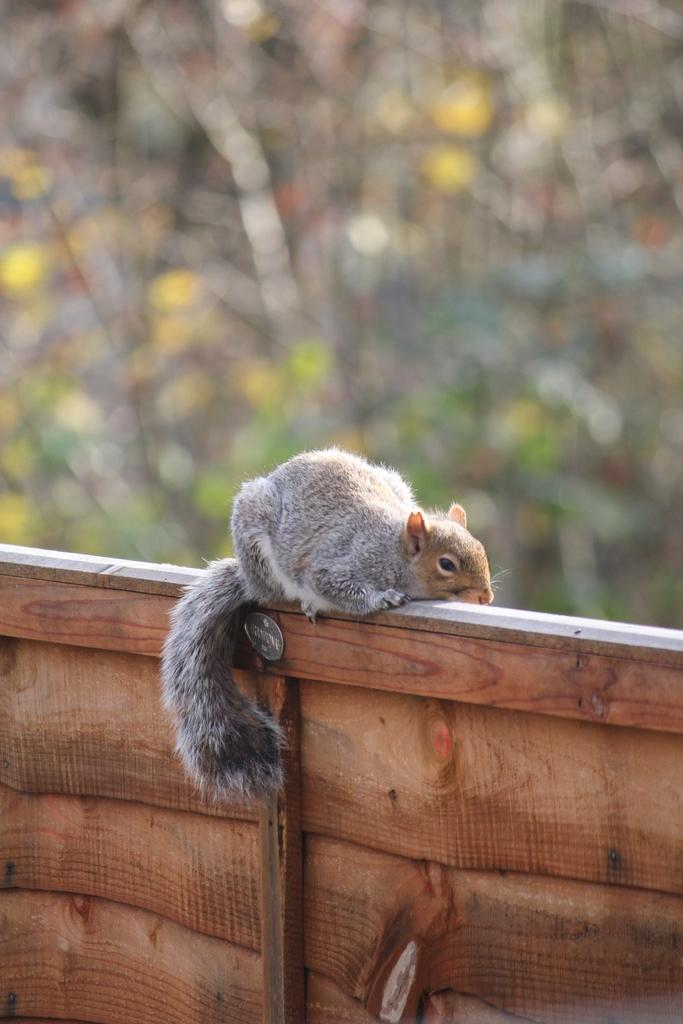What animal is present in the image? There is a squirrel in the image. Can you describe the coloration of the squirrel? The squirrel has a white, ash, and brown coloration. Where is the squirrel located in the image? The squirrel is on a wooden wall. What can be seen in the background of the image? There are trees in the background of the image. How are the trees in the background depicted? The trees in the background are blurred. What type of tooth is visible in the image? There is no tooth present in the image; it features a squirrel on a wooden wall with trees in the background. What color is the shirt worn by the squirrel in the image? Squirrels do not wear shirts, and there is no clothing item present in the image. 